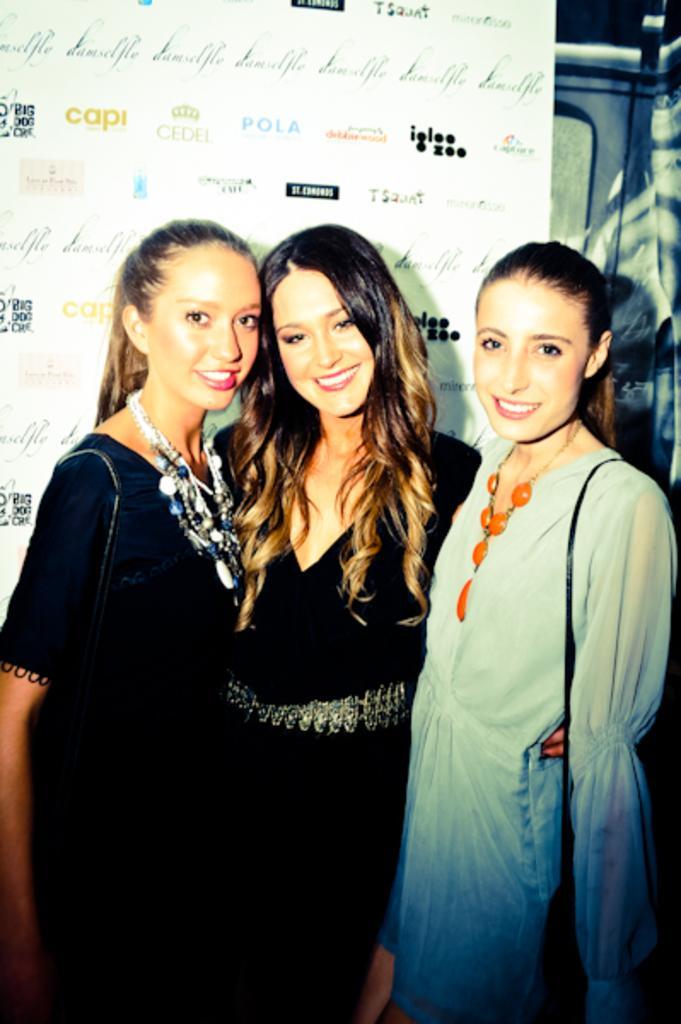Could you give a brief overview of what you see in this image? There are three girls in front of the picture and three of them are smiling. Behind them, we see a banner containing text. This picture might be clicked on a program. 